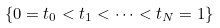Convert formula to latex. <formula><loc_0><loc_0><loc_500><loc_500>\left \{ 0 = t _ { 0 } < t _ { 1 } < \dots < t _ { N } = 1 \right \}</formula> 